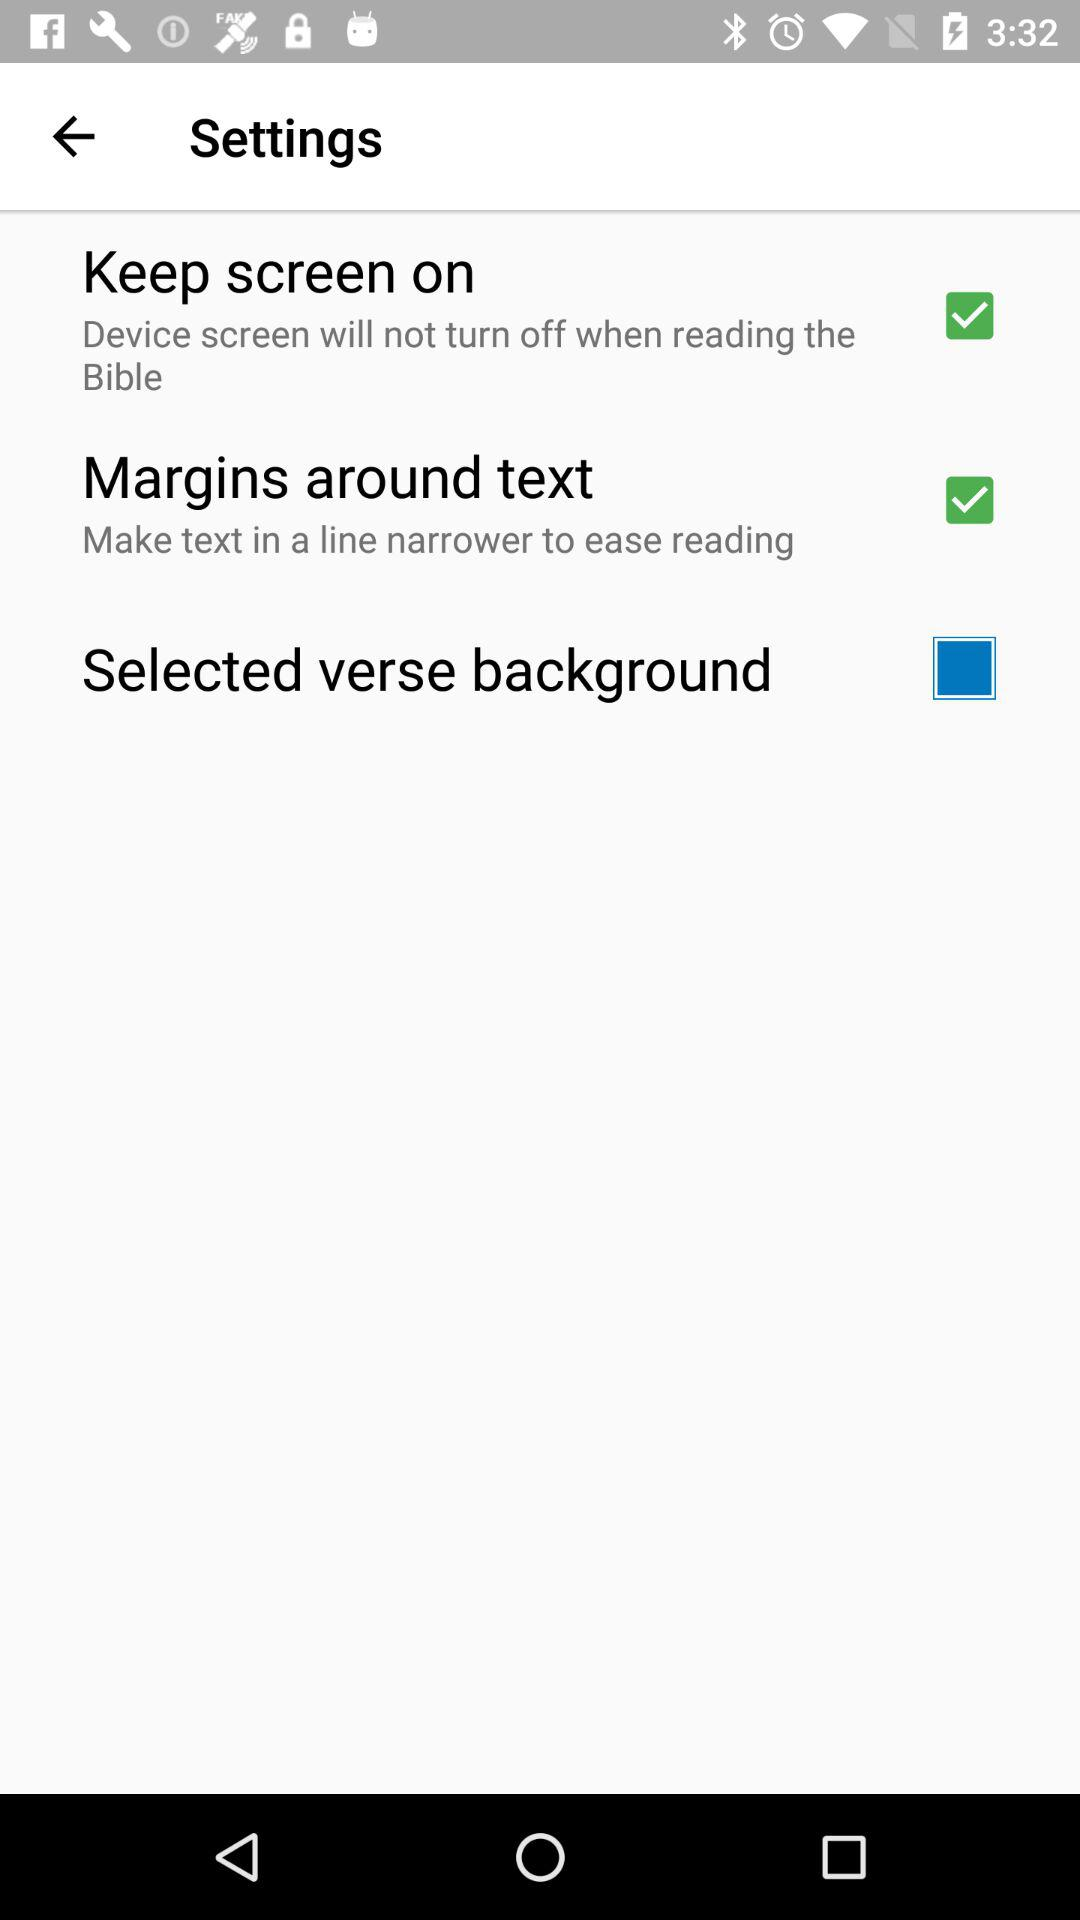Which settings have been checked? The checked settings are "Keep screen on" and "Margins around text". 